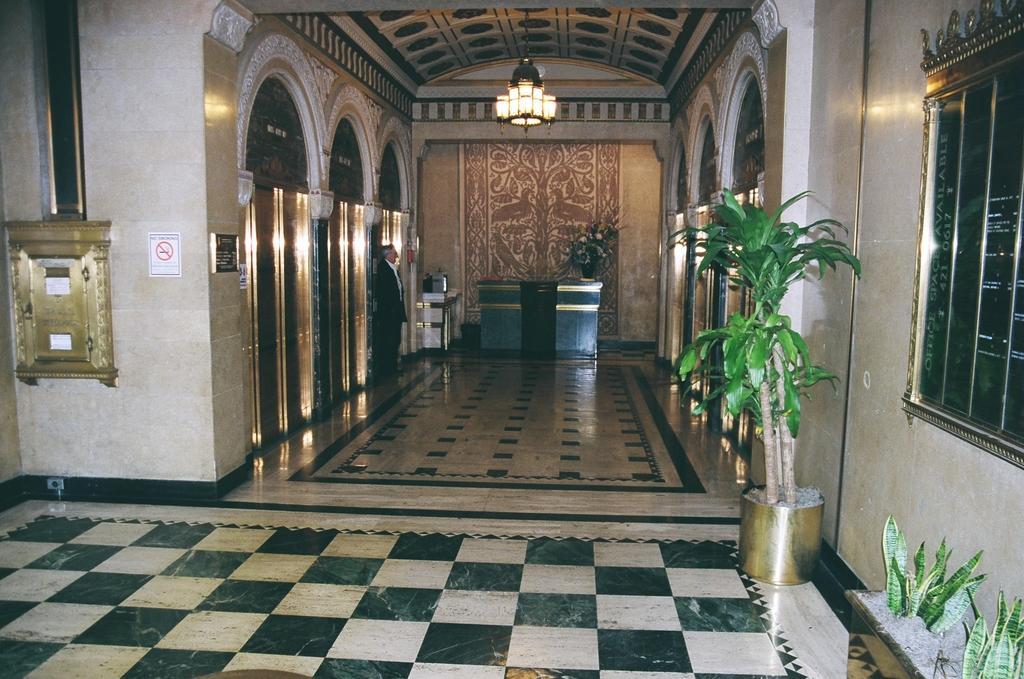Please provide a concise description of this image. In this image on the right side, I can see the plants. On the left side, I can see a board with some text written on it. I can also see a person standing near the wall. In the middle I can see the floor. I can also see a flower flask on the table. At the top I can see the lights. 